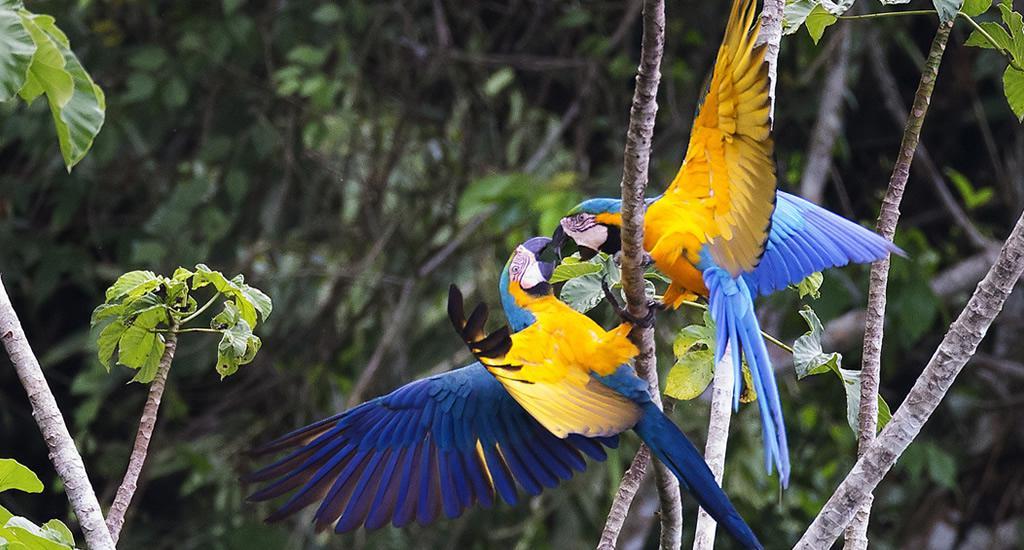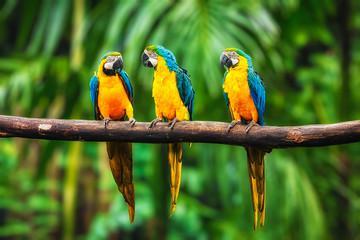The first image is the image on the left, the second image is the image on the right. Examine the images to the left and right. Is the description "There are exactly three parrots in the right image standing on a branch." accurate? Answer yes or no. Yes. 